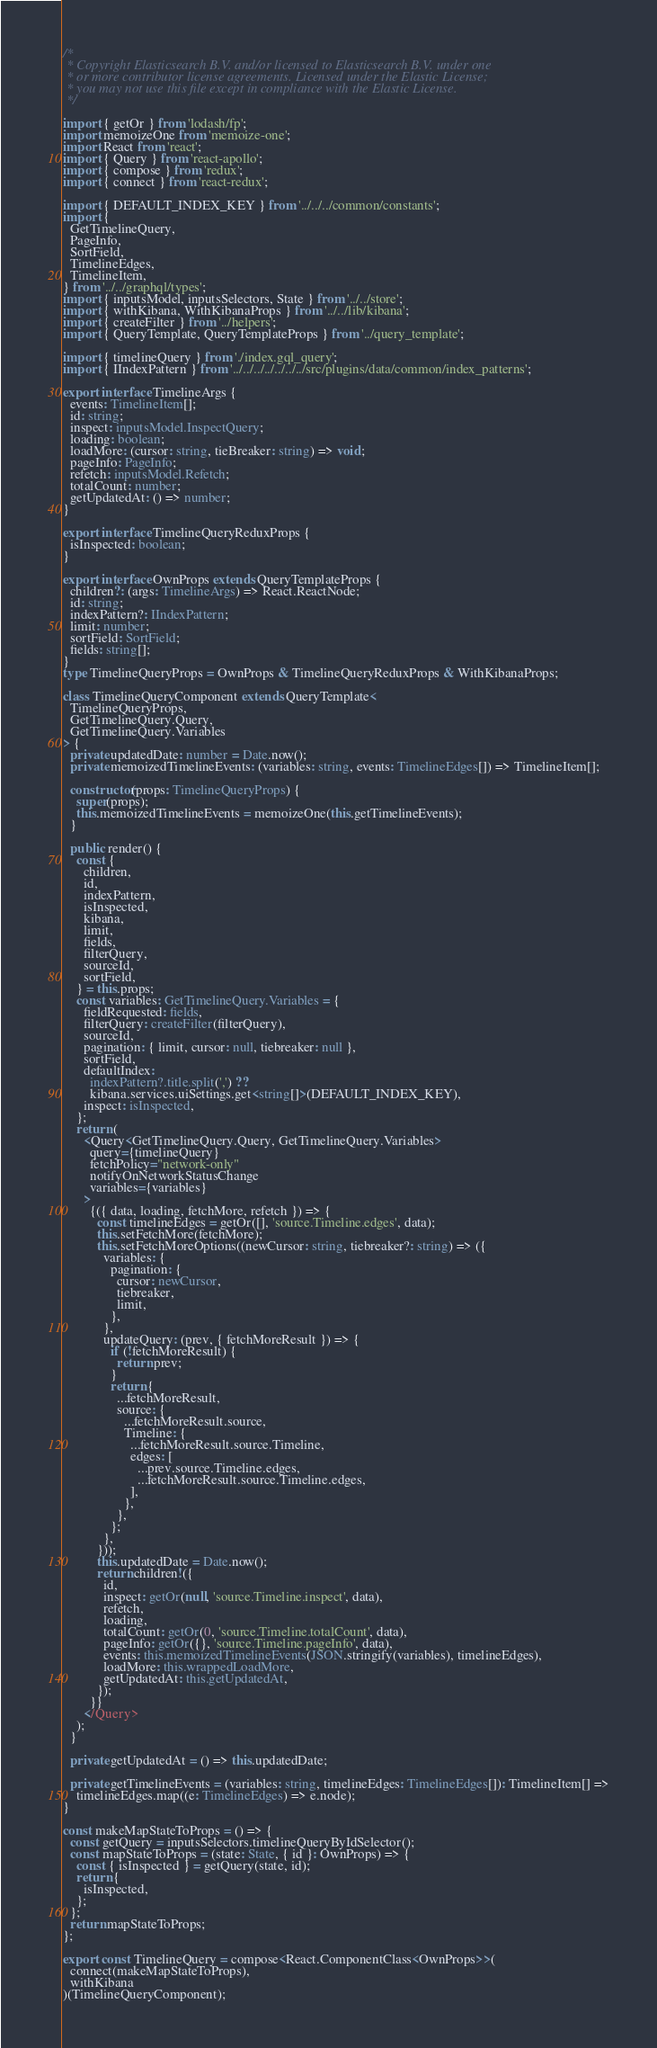Convert code to text. <code><loc_0><loc_0><loc_500><loc_500><_TypeScript_>/*
 * Copyright Elasticsearch B.V. and/or licensed to Elasticsearch B.V. under one
 * or more contributor license agreements. Licensed under the Elastic License;
 * you may not use this file except in compliance with the Elastic License.
 */

import { getOr } from 'lodash/fp';
import memoizeOne from 'memoize-one';
import React from 'react';
import { Query } from 'react-apollo';
import { compose } from 'redux';
import { connect } from 'react-redux';

import { DEFAULT_INDEX_KEY } from '../../../common/constants';
import {
  GetTimelineQuery,
  PageInfo,
  SortField,
  TimelineEdges,
  TimelineItem,
} from '../../graphql/types';
import { inputsModel, inputsSelectors, State } from '../../store';
import { withKibana, WithKibanaProps } from '../../lib/kibana';
import { createFilter } from '../helpers';
import { QueryTemplate, QueryTemplateProps } from '../query_template';

import { timelineQuery } from './index.gql_query';
import { IIndexPattern } from '../../../../../../../src/plugins/data/common/index_patterns';

export interface TimelineArgs {
  events: TimelineItem[];
  id: string;
  inspect: inputsModel.InspectQuery;
  loading: boolean;
  loadMore: (cursor: string, tieBreaker: string) => void;
  pageInfo: PageInfo;
  refetch: inputsModel.Refetch;
  totalCount: number;
  getUpdatedAt: () => number;
}

export interface TimelineQueryReduxProps {
  isInspected: boolean;
}

export interface OwnProps extends QueryTemplateProps {
  children?: (args: TimelineArgs) => React.ReactNode;
  id: string;
  indexPattern?: IIndexPattern;
  limit: number;
  sortField: SortField;
  fields: string[];
}
type TimelineQueryProps = OwnProps & TimelineQueryReduxProps & WithKibanaProps;

class TimelineQueryComponent extends QueryTemplate<
  TimelineQueryProps,
  GetTimelineQuery.Query,
  GetTimelineQuery.Variables
> {
  private updatedDate: number = Date.now();
  private memoizedTimelineEvents: (variables: string, events: TimelineEdges[]) => TimelineItem[];

  constructor(props: TimelineQueryProps) {
    super(props);
    this.memoizedTimelineEvents = memoizeOne(this.getTimelineEvents);
  }

  public render() {
    const {
      children,
      id,
      indexPattern,
      isInspected,
      kibana,
      limit,
      fields,
      filterQuery,
      sourceId,
      sortField,
    } = this.props;
    const variables: GetTimelineQuery.Variables = {
      fieldRequested: fields,
      filterQuery: createFilter(filterQuery),
      sourceId,
      pagination: { limit, cursor: null, tiebreaker: null },
      sortField,
      defaultIndex:
        indexPattern?.title.split(',') ??
        kibana.services.uiSettings.get<string[]>(DEFAULT_INDEX_KEY),
      inspect: isInspected,
    };
    return (
      <Query<GetTimelineQuery.Query, GetTimelineQuery.Variables>
        query={timelineQuery}
        fetchPolicy="network-only"
        notifyOnNetworkStatusChange
        variables={variables}
      >
        {({ data, loading, fetchMore, refetch }) => {
          const timelineEdges = getOr([], 'source.Timeline.edges', data);
          this.setFetchMore(fetchMore);
          this.setFetchMoreOptions((newCursor: string, tiebreaker?: string) => ({
            variables: {
              pagination: {
                cursor: newCursor,
                tiebreaker,
                limit,
              },
            },
            updateQuery: (prev, { fetchMoreResult }) => {
              if (!fetchMoreResult) {
                return prev;
              }
              return {
                ...fetchMoreResult,
                source: {
                  ...fetchMoreResult.source,
                  Timeline: {
                    ...fetchMoreResult.source.Timeline,
                    edges: [
                      ...prev.source.Timeline.edges,
                      ...fetchMoreResult.source.Timeline.edges,
                    ],
                  },
                },
              };
            },
          }));
          this.updatedDate = Date.now();
          return children!({
            id,
            inspect: getOr(null, 'source.Timeline.inspect', data),
            refetch,
            loading,
            totalCount: getOr(0, 'source.Timeline.totalCount', data),
            pageInfo: getOr({}, 'source.Timeline.pageInfo', data),
            events: this.memoizedTimelineEvents(JSON.stringify(variables), timelineEdges),
            loadMore: this.wrappedLoadMore,
            getUpdatedAt: this.getUpdatedAt,
          });
        }}
      </Query>
    );
  }

  private getUpdatedAt = () => this.updatedDate;

  private getTimelineEvents = (variables: string, timelineEdges: TimelineEdges[]): TimelineItem[] =>
    timelineEdges.map((e: TimelineEdges) => e.node);
}

const makeMapStateToProps = () => {
  const getQuery = inputsSelectors.timelineQueryByIdSelector();
  const mapStateToProps = (state: State, { id }: OwnProps) => {
    const { isInspected } = getQuery(state, id);
    return {
      isInspected,
    };
  };
  return mapStateToProps;
};

export const TimelineQuery = compose<React.ComponentClass<OwnProps>>(
  connect(makeMapStateToProps),
  withKibana
)(TimelineQueryComponent);
</code> 